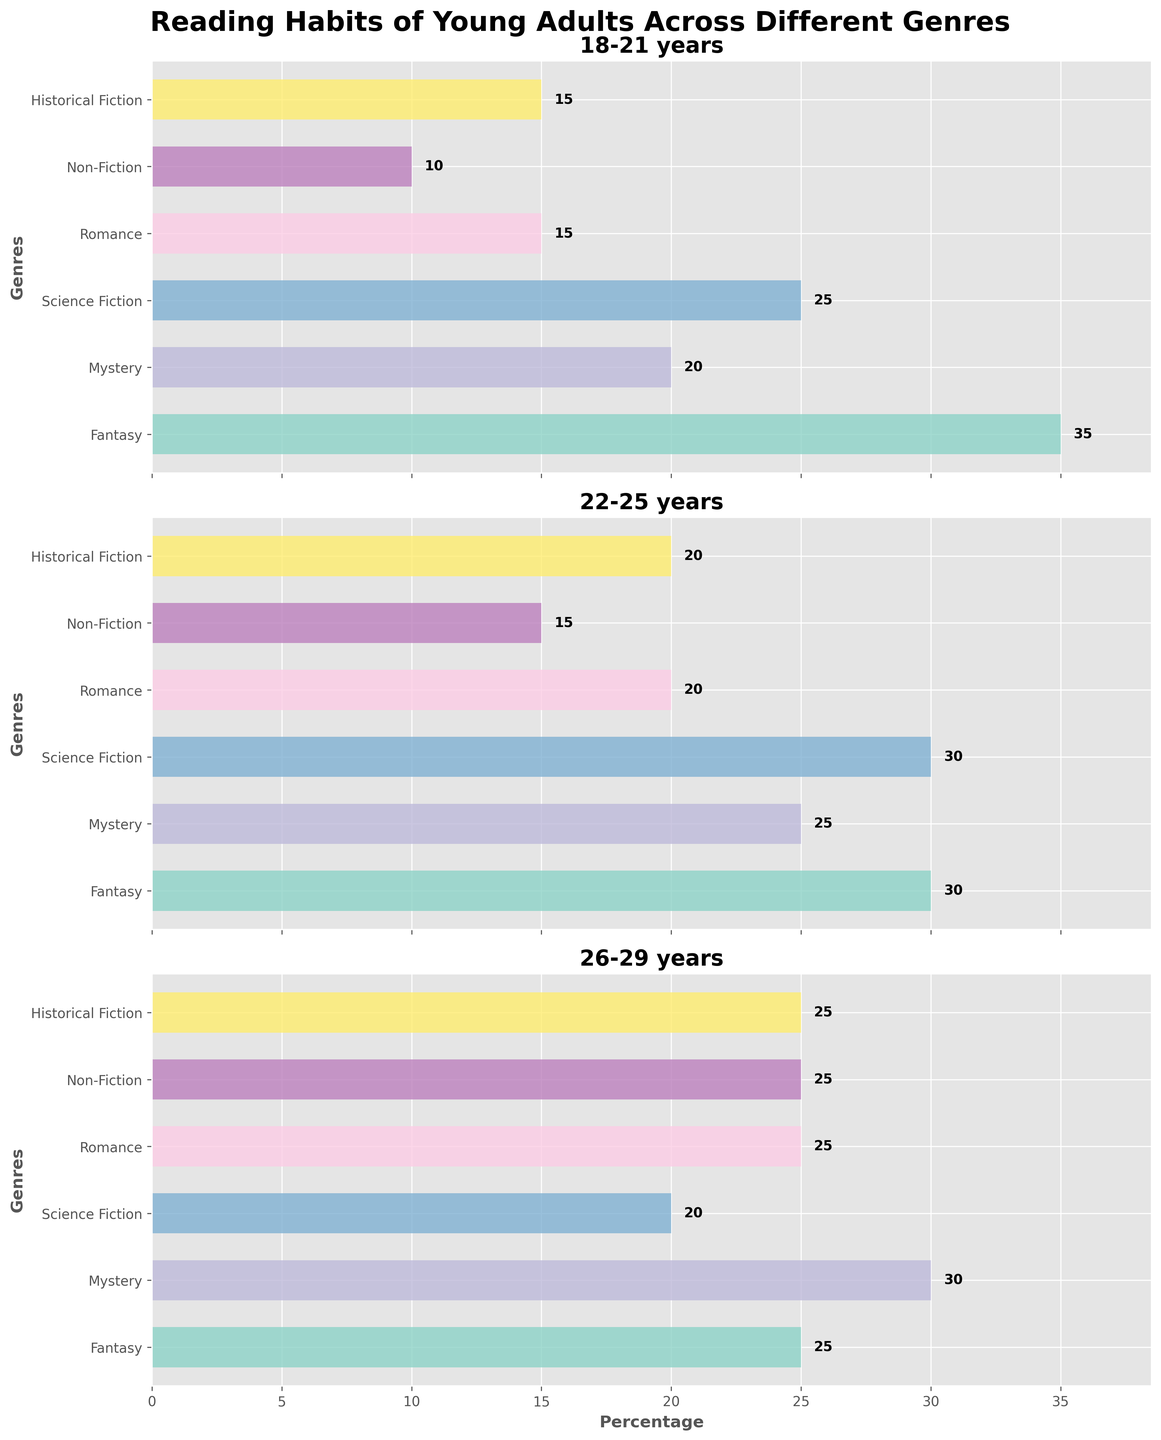What age group reads the most fantasy books? The bar for Fantasy books is the longest in the 18-21 years age category.
Answer: 18-21 years Which genre is the least popular among 18-21 years old? The shortest bar in the 18-21 years subplot corresponds to Non-Fiction.
Answer: Non-Fiction Compare the preference for Romance books between the 22-25 and 26-29 age groups. The length of the bar for Romance books is 20% for 22-25 years and 25% for 26-29 years.
Answer: 26-29 years What is the aggregate percentage of young adults in the 26-29 years group who read Mystery and Fantasy books? The bar lengths for Mystery and Fantasy in the 26-29 years group are 30% and 25% respectively, adding up to 55%.
Answer: 55% In which age group is Science Fiction the most popular? The longest bar for Science Fiction is observed in the 22-25 years age group.
Answer: 22-25 years What is the total percentage of young adults in the 18-21 years category who read Mystery, Science Fiction, and Historical Fiction combined? Adding the bar lengths for Mystery (20%), Science Fiction (25%), and Historical Fiction (15%) gives a total of 60%.
Answer: 60% Is the popularity of Non-Fiction books consistent across all age groups? In the subplots, Non-Fiction books show 10% in 18-21 years, 15% in 22-25 years, and 25% in 26-29 years, indicating an increasing trend.
Answer: No Which genre has the shortest bar in the 22-25 years age group? The subplot for the 22-25 years group shows the shortest bar for Non-Fiction.
Answer: Non-Fiction How does the popularity of Historical Fiction among the 18-21 years group compare to the 26-29 years group? The 18-21 years group shows a 15% bar length for Historical Fiction, while the 26-29 years group has a 25% bar length.
Answer: Less popular in the 18-21 years group 